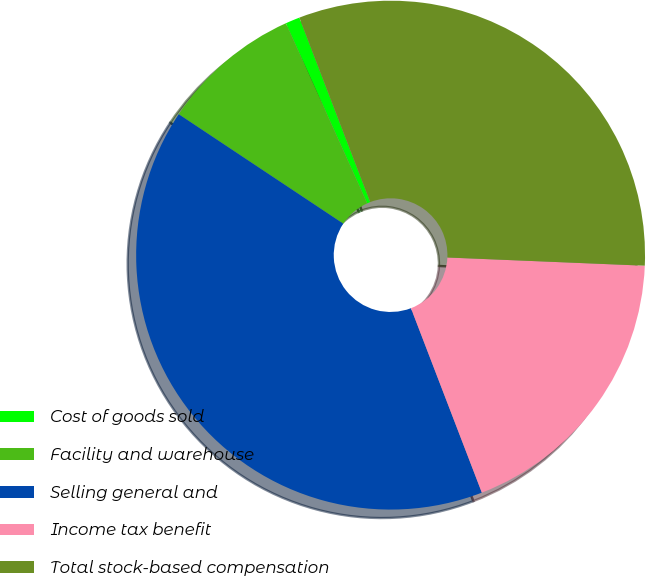<chart> <loc_0><loc_0><loc_500><loc_500><pie_chart><fcel>Cost of goods sold<fcel>Facility and warehouse<fcel>Selling general and<fcel>Income tax benefit<fcel>Total stock-based compensation<nl><fcel>0.91%<fcel>8.91%<fcel>40.18%<fcel>18.5%<fcel>31.5%<nl></chart> 